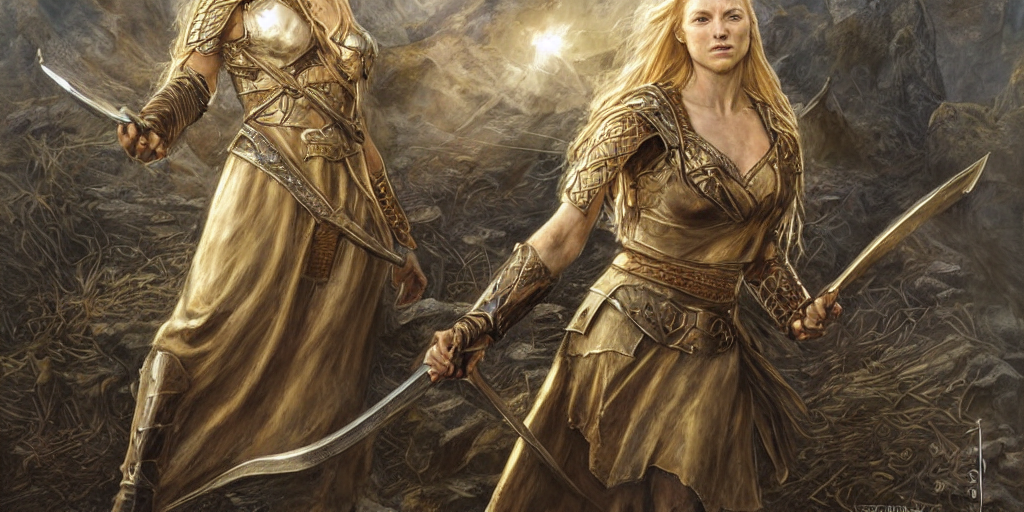What can you infer about the setting these characters are in? The background features a rocky and barren landscape, possibly a battlefield or an untamed wilderness. The warm hues and the backlit atmosphere may indicate the scene is set during either sunrise or sunset, adding a dramatic effect that heightens the impact of the image. 